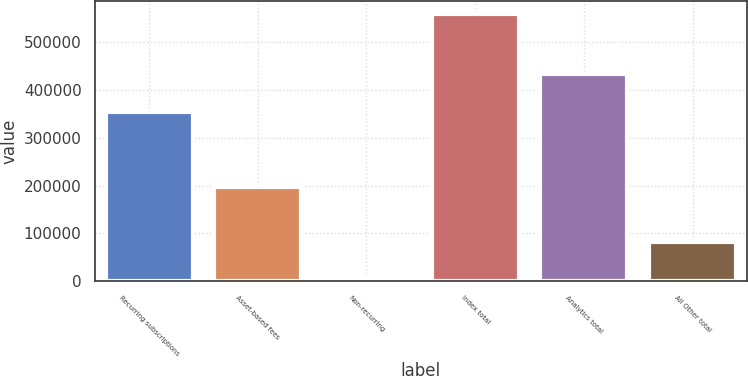Convert chart. <chart><loc_0><loc_0><loc_500><loc_500><bar_chart><fcel>Recurring subscriptions<fcel>Asset-based fees<fcel>Non-recurring<fcel>Index total<fcel>Analytics total<fcel>All Other total<nl><fcel>353136<fcel>197974<fcel>7854<fcel>558964<fcel>433424<fcel>82625<nl></chart> 